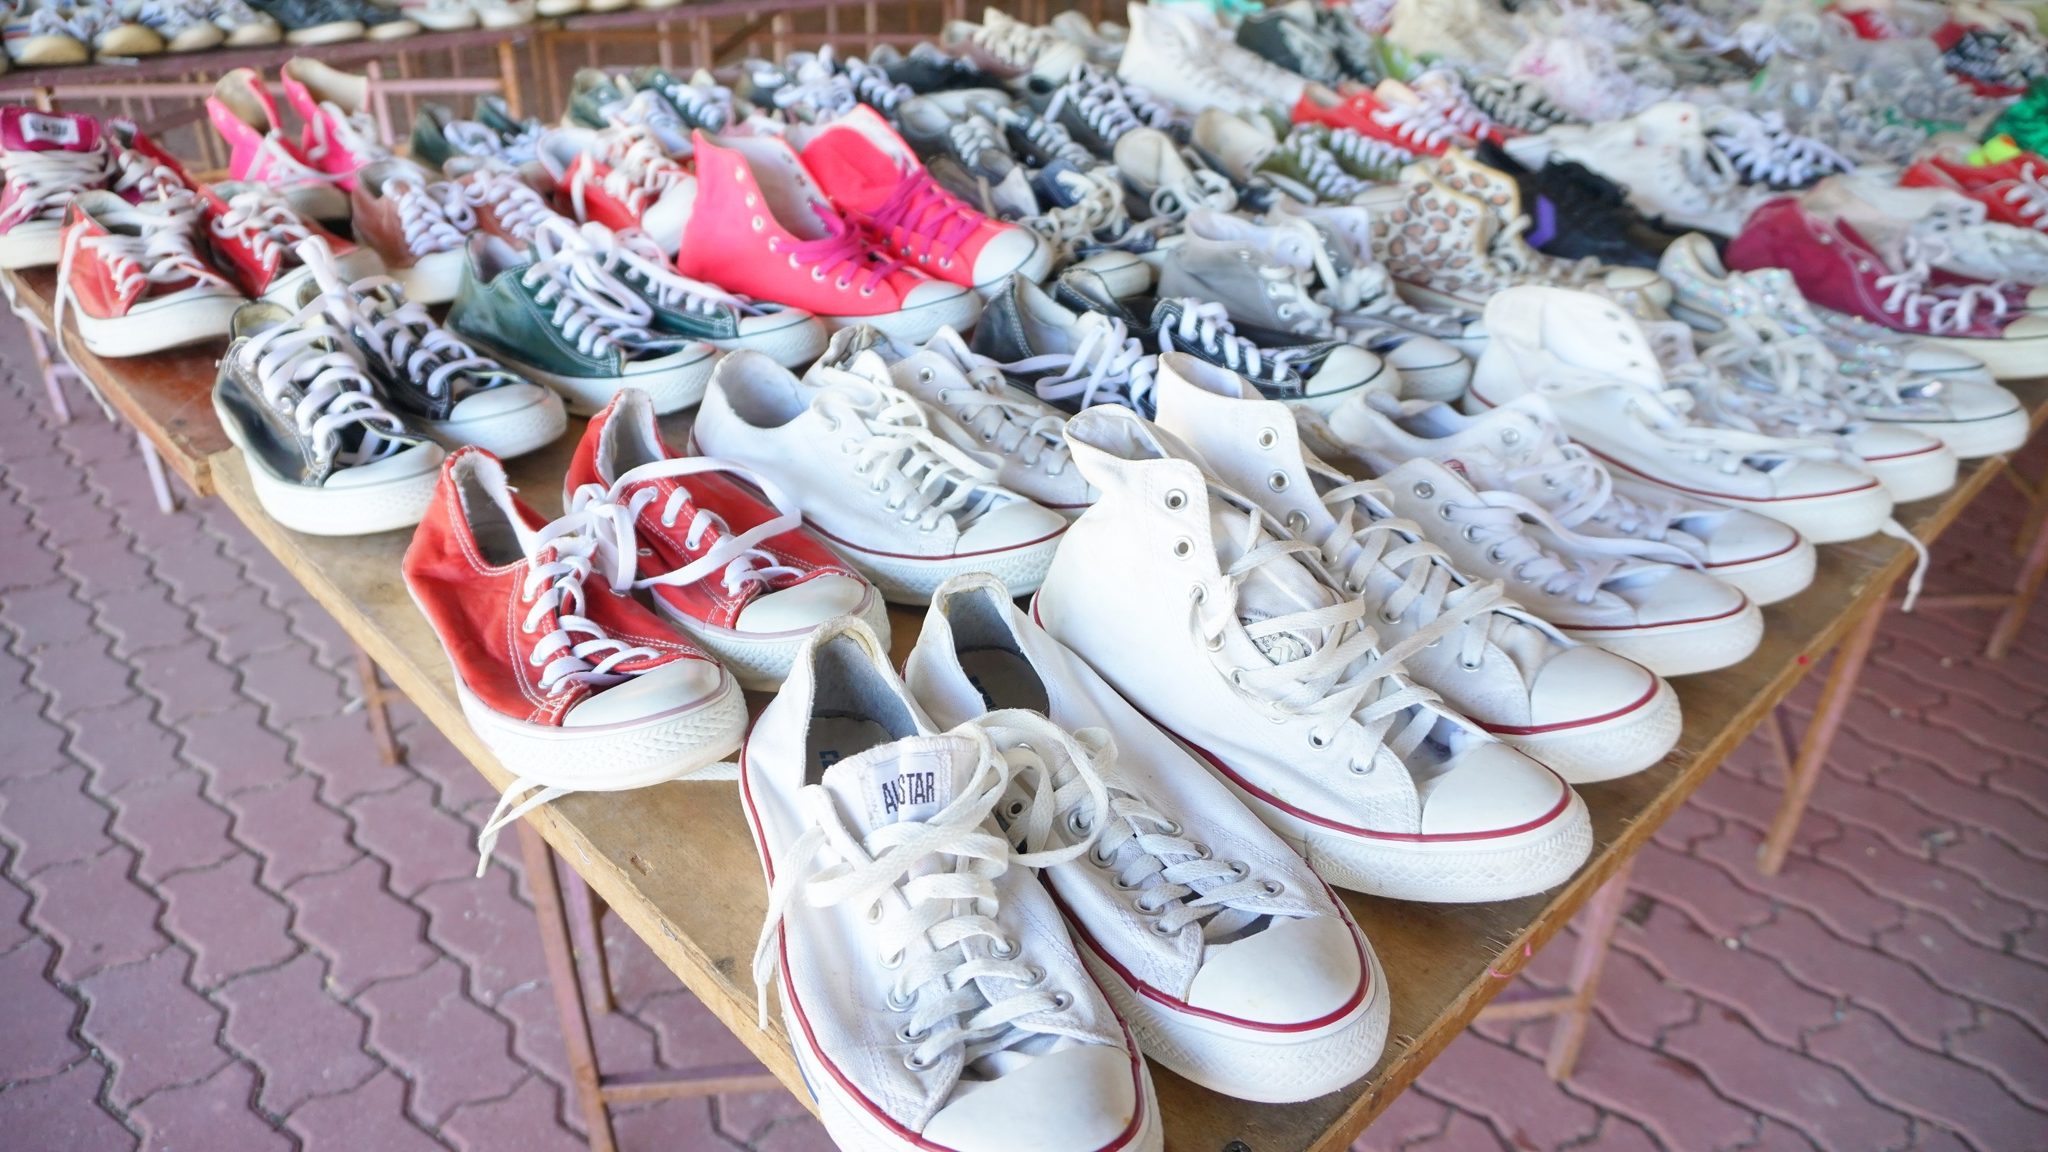What kind of events could these sneakers have been through? These sneakers might have seen a myriad of events, from casual daily walks in the park to intense sports activities. Some could have danced through lively music festivals or carried someone on a grand travel adventure. Others might have been worn on first dates, in protest marches, or during community service. Each pair potentially holds memories of its own, hinting at the varied, vibrant lives their previous owners have led. Imagine a sneaker-themed festival. What would it be like? A sneaker-themed festival would be a vibrant celebration of footwear culture. The venue would be adorned with colorful displays of sneakers from various eras and brands, with sections dedicated to rare and vintage collections. Workshops could offer insights into sneaker customization, care, and history. Stalls would sell limited-edition footwear, while performance artists might create sneaker-inspired art. Interactive zones would feature sneaker obstacle courses and competitive timed sports activities. Fashion shows would spotlight innovative designs, and guest speakers from the sneaker and fashion industries could share their insights. The festival would draw enthusiasts of all ages, creating a bustling and diverse community united by their love of sneakers. 